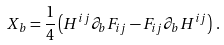<formula> <loc_0><loc_0><loc_500><loc_500>X _ { b } = \frac { 1 } { 4 } \left ( H ^ { i j } \partial _ { b } F _ { i j } - F _ { i j } \partial _ { b } H ^ { i j } \right ) \, .</formula> 